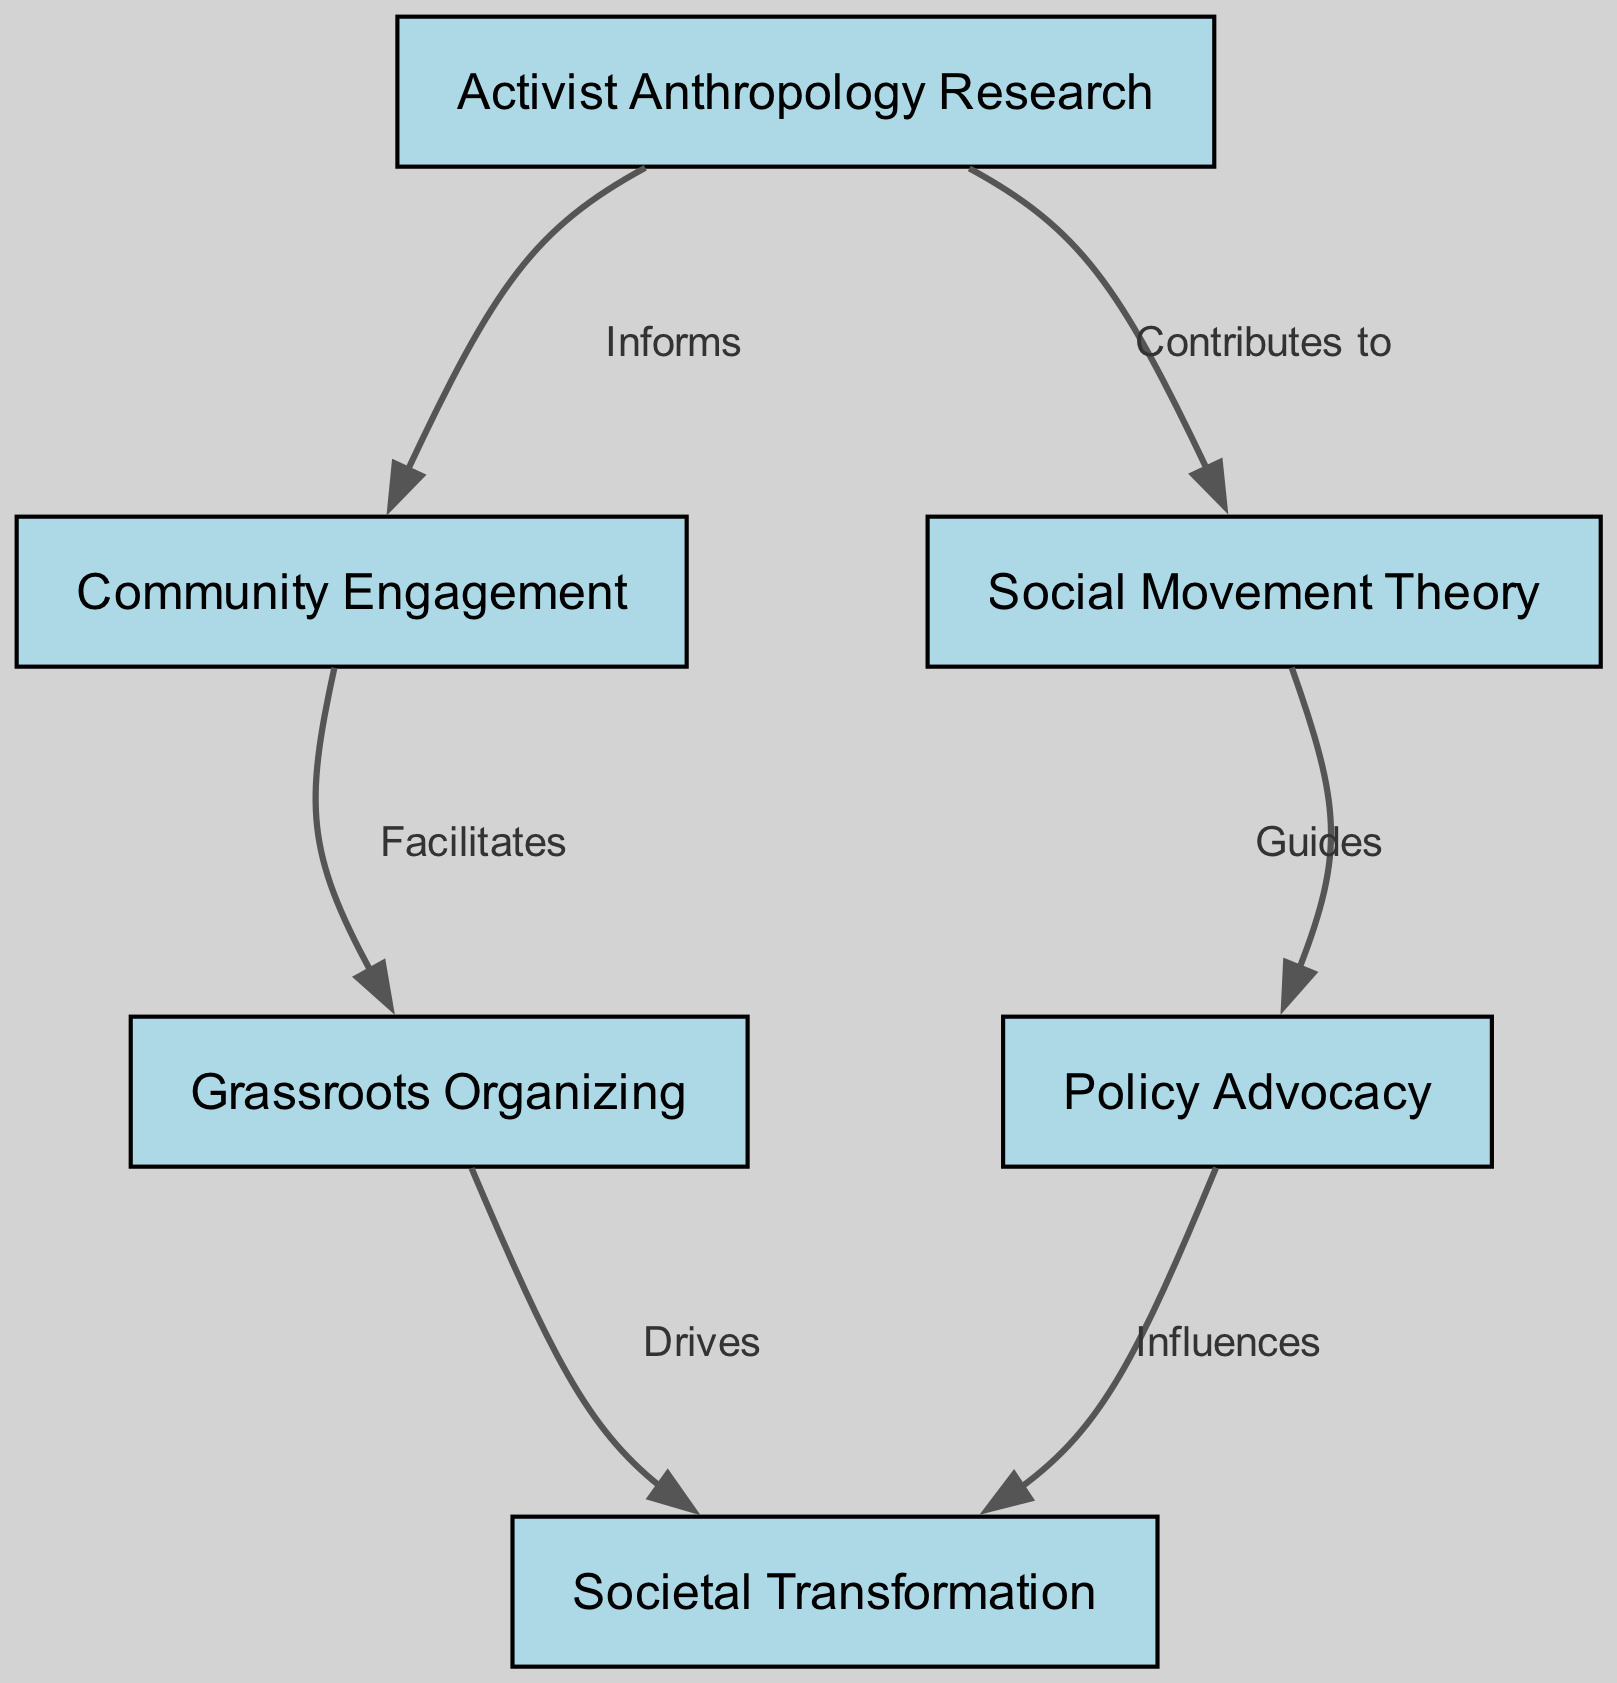What is the total number of nodes in the diagram? The diagram consists of six distinct nodes: "Activist Anthropology Research," "Community Engagement," "Social Movement Theory," "Policy Advocacy," "Grassroots Organizing," and "Societal Transformation." Counting these gives a total of six nodes.
Answer: 6 What type of relationship exists between "Activist Anthropology Research" and "Community Engagement"? The relationship is labeled as "Informs," indicating that the "Activist Anthropology Research" contributes knowledge or insights that inform the "Community Engagement" activities.
Answer: Informs How many edges are leading from "Community Engagement"? Two edges lead from "Community Engagement" to "Grassroots Organizing" and from "Activist Anthropology Research," indicating the flow of influence or facilitation from this node to others.
Answer: 2 What does "Social Movement Theory" guide in the diagram? "Social Movement Theory" guides "Policy Advocacy," showing its role in shaping or directing efforts towards influencing a particular policy.
Answer: Policy Advocacy Which node has the most influence on "Societal Transformation"? Two nodes have direct influences on "Societal Transformation": "Policy Advocacy" and "Grassroots Organizing." However, since both contribute to driving change, either can be seen as influential regarding this outcome.
Answer: Policy Advocacy, Grassroots Organizing What is the relationship between "Grassroots Organizing" and "Societal Transformation"? The relationship is labeled as "Drives," indicating that "Grassroots Organizing" actively propels or pushes forward the process of "Societal Transformation."
Answer: Drives How does "Activist Anthropology Research" relate to "Social Movement Theory"? The relationship is labeled "Contributes to," indicating that insights or findings from "Activist Anthropology Research" provide valuable context or support for understanding "Social Movement Theory."
Answer: Contributes to What is the direction of influence from "Policy Advocacy"? "Policy Advocacy" influences "Societal Transformation," representing a flow of impact where advocacy efforts are aimed at achieving social change.
Answer: Influences How many relationships are there in total within the diagram? There are a total of five edges connecting the six nodes, marking the relationships or flows of influence among them.
Answer: 5 